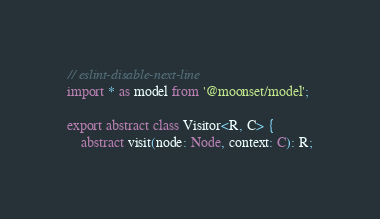<code> <loc_0><loc_0><loc_500><loc_500><_TypeScript_>// eslint-disable-next-line
import * as model from '@moonset/model';

export abstract class Visitor<R, C> {
    abstract visit(node: Node, context: C): R;
</code> 